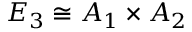Convert formula to latex. <formula><loc_0><loc_0><loc_500><loc_500>E _ { 3 } \cong A _ { 1 } \times A _ { 2 }</formula> 